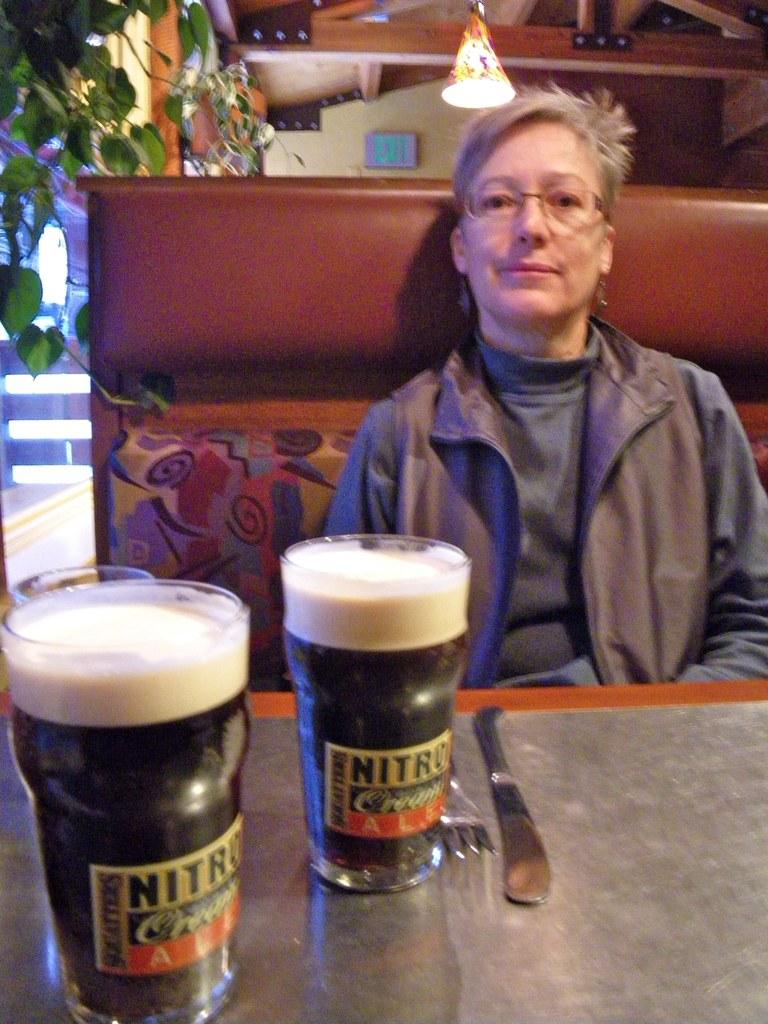What is inside the glass?
Give a very brief answer. Ale. What's the name of the brewery?
Your answer should be very brief. Nitro. 